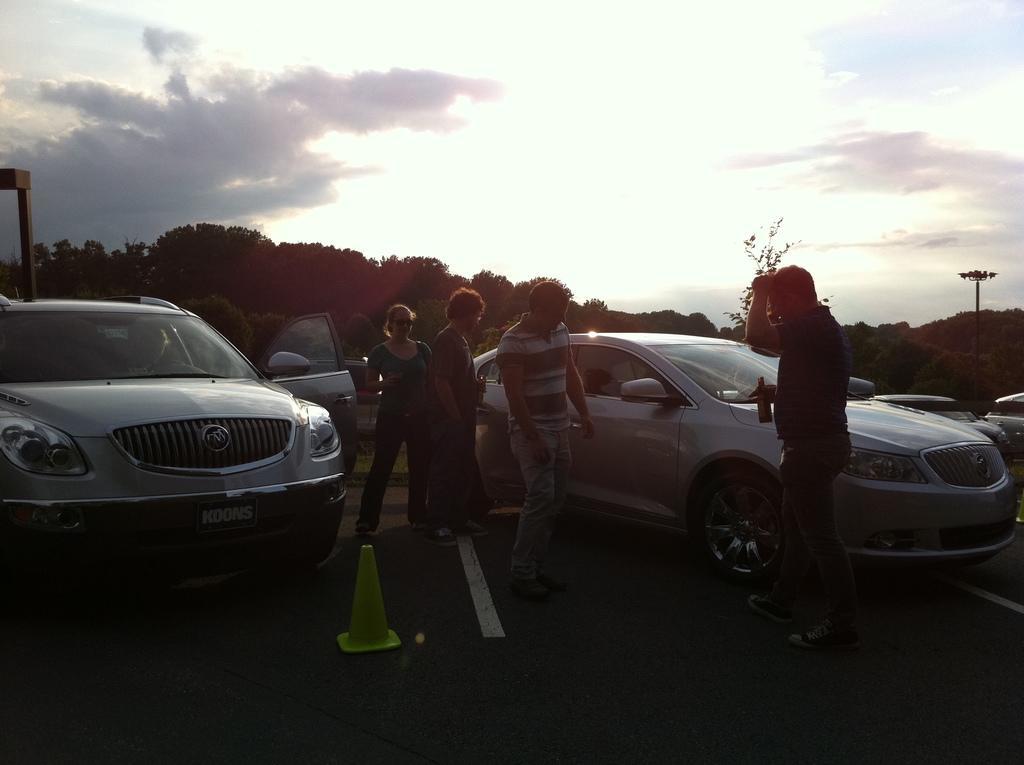Describe this image in one or two sentences. In this image there are three persons standing in middle of this image and one more person standing at right side of this image is holding one bottle. There is one car at right side of this image and one more car is at left side of this image. There are some trees in the background and there is one pole at right side of this image and there is a sky at top of this image. 